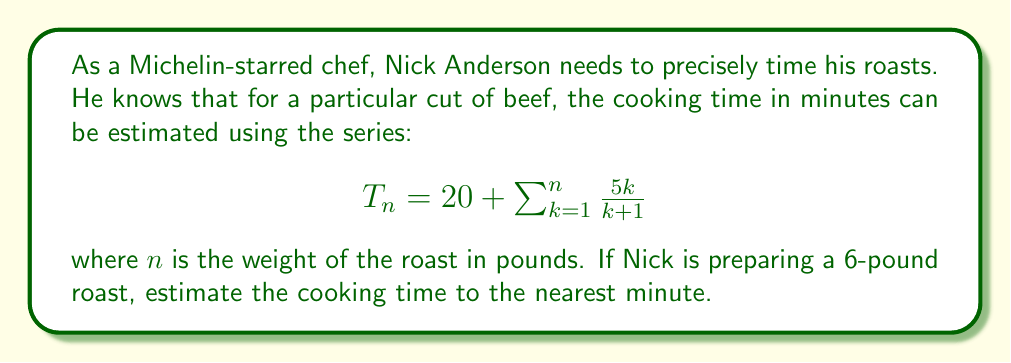Can you solve this math problem? To solve this problem, we need to calculate the sum of the series up to $n=6$:

1) First, let's expand the series:

   $$T_6 = 20 + \frac{5(1)}{1+1} + \frac{5(2)}{2+1} + \frac{5(3)}{3+1} + \frac{5(4)}{4+1} + \frac{5(5)}{5+1} + \frac{5(6)}{6+1}$$

2) Now, let's calculate each term:

   $$T_6 = 20 + \frac{5}{2} + \frac{10}{3} + \frac{15}{4} + \frac{20}{5} + \frac{25}{6} + \frac{30}{7}$$

3) Simplifying:

   $$T_6 = 20 + 2.5 + 3.33 + 3.75 + 4 + 4.17 + 4.29$$

4) Adding all terms:

   $$T_6 = 42.04$$

5) Rounding to the nearest minute:

   $$T_6 \approx 42 \text{ minutes}$$

Therefore, the estimated cooking time for a 6-pound roast is 42 minutes.
Answer: 42 minutes 